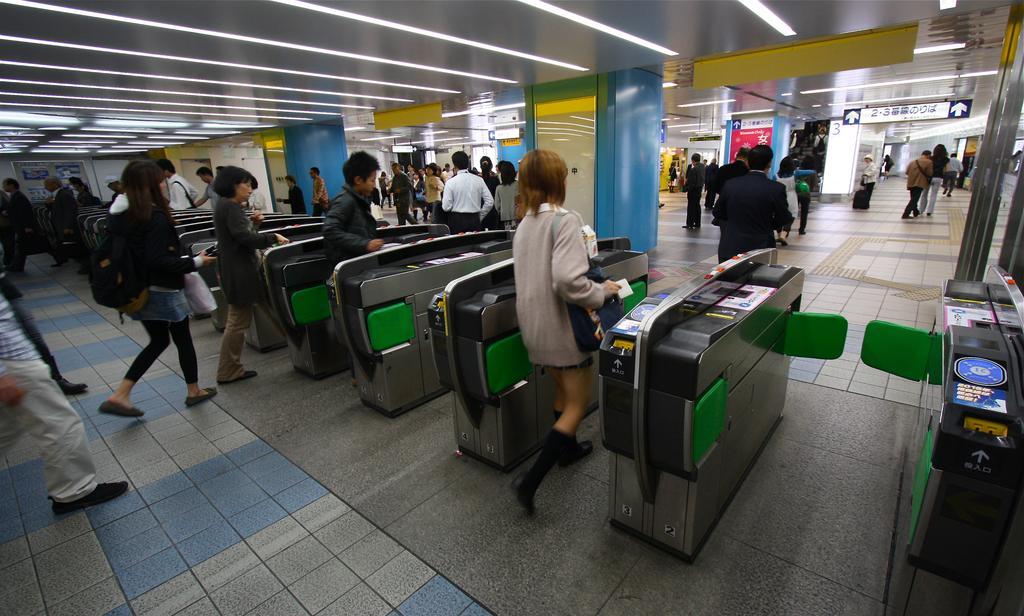Can you describe this image briefly? In this image we can see persons standing on the floor, automatic entry gates, sign boards, name boards and stores. 